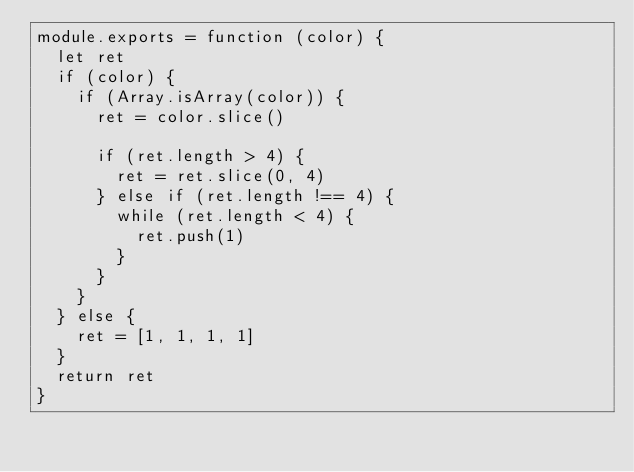Convert code to text. <code><loc_0><loc_0><loc_500><loc_500><_JavaScript_>module.exports = function (color) {
  let ret
  if (color) {
    if (Array.isArray(color)) {
      ret = color.slice()

      if (ret.length > 4) {
        ret = ret.slice(0, 4)
      } else if (ret.length !== 4) {
        while (ret.length < 4) {
          ret.push(1)
        }
      }
    }
  } else {
    ret = [1, 1, 1, 1]
  }
  return ret
}
</code> 